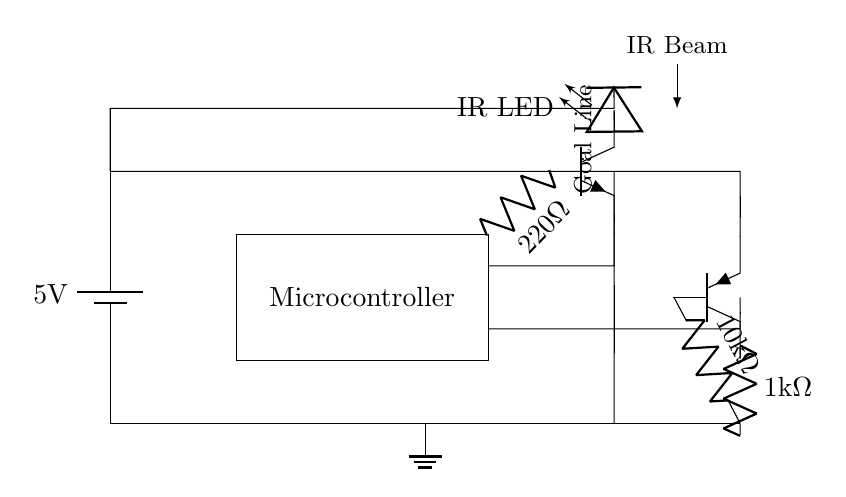What is the voltage of the power supply in this circuit? The circuit uses a battery with a specified voltage of 5 volts, which can be seen near the battery symbol.
Answer: 5 volts What type of sensor is used for detection in this system? The circuit includes an infrared LED and an infrared receiver, indicating that infrared sensors are used for detection.
Answer: Infrared sensors What is the resistance value connected to the infrared emitter? The circuit diagram shows a resistor of 220 ohms connected in series with the IR LED, labeled next to the resistor symbol.
Answer: 220 ohms What type of microcontroller is used in this circuit? The circuit does not specify the model of the microcontroller; it is simply labeled as "Microcontroller." Therefore, the specific type is unknown based on the diagram.
Answer: Microcontroller Which component is responsible for receiving the infrared signals? The PNP transistor labeled as T2 serves as the infrared receiver in this circuit, as indicated in the diagram.
Answer: Infrared receiver What is the purpose of the ground connection in this circuit? The ground connection provides a common reference point for all components in the circuit, ensuring stability and completing the circuit path.
Answer: Common reference 